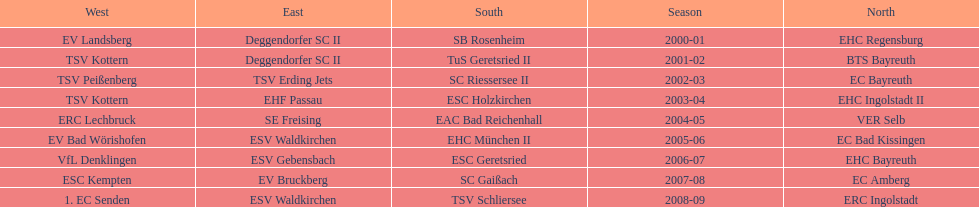The only team to win the north in 2000-01 season? EHC Regensburg. 